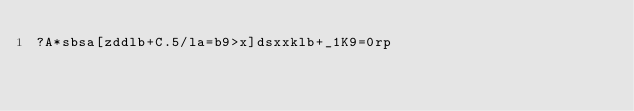Convert code to text. <code><loc_0><loc_0><loc_500><loc_500><_dc_>?A*sbsa[zddlb+C.5/la=b9>x]dsxxklb+_1K9=0rp</code> 